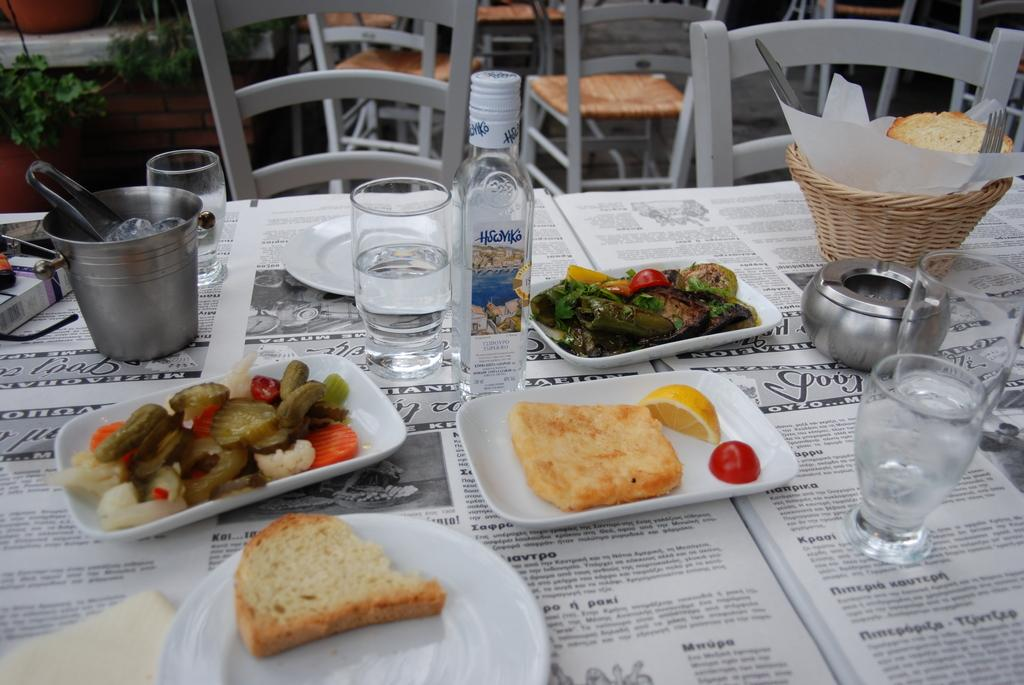What type of furniture is present in the image? There are chairs and tables in the image. What are the tables used for in the image? There are objects placed on the tables, suggesting they are being used for support or display. Where are the plant pots located in the image? The plant pots are at the left side of the image. What type of lettuce is being used as a reason for the loaf in the image? There is no lettuce, reason, or loaf present in the image. 